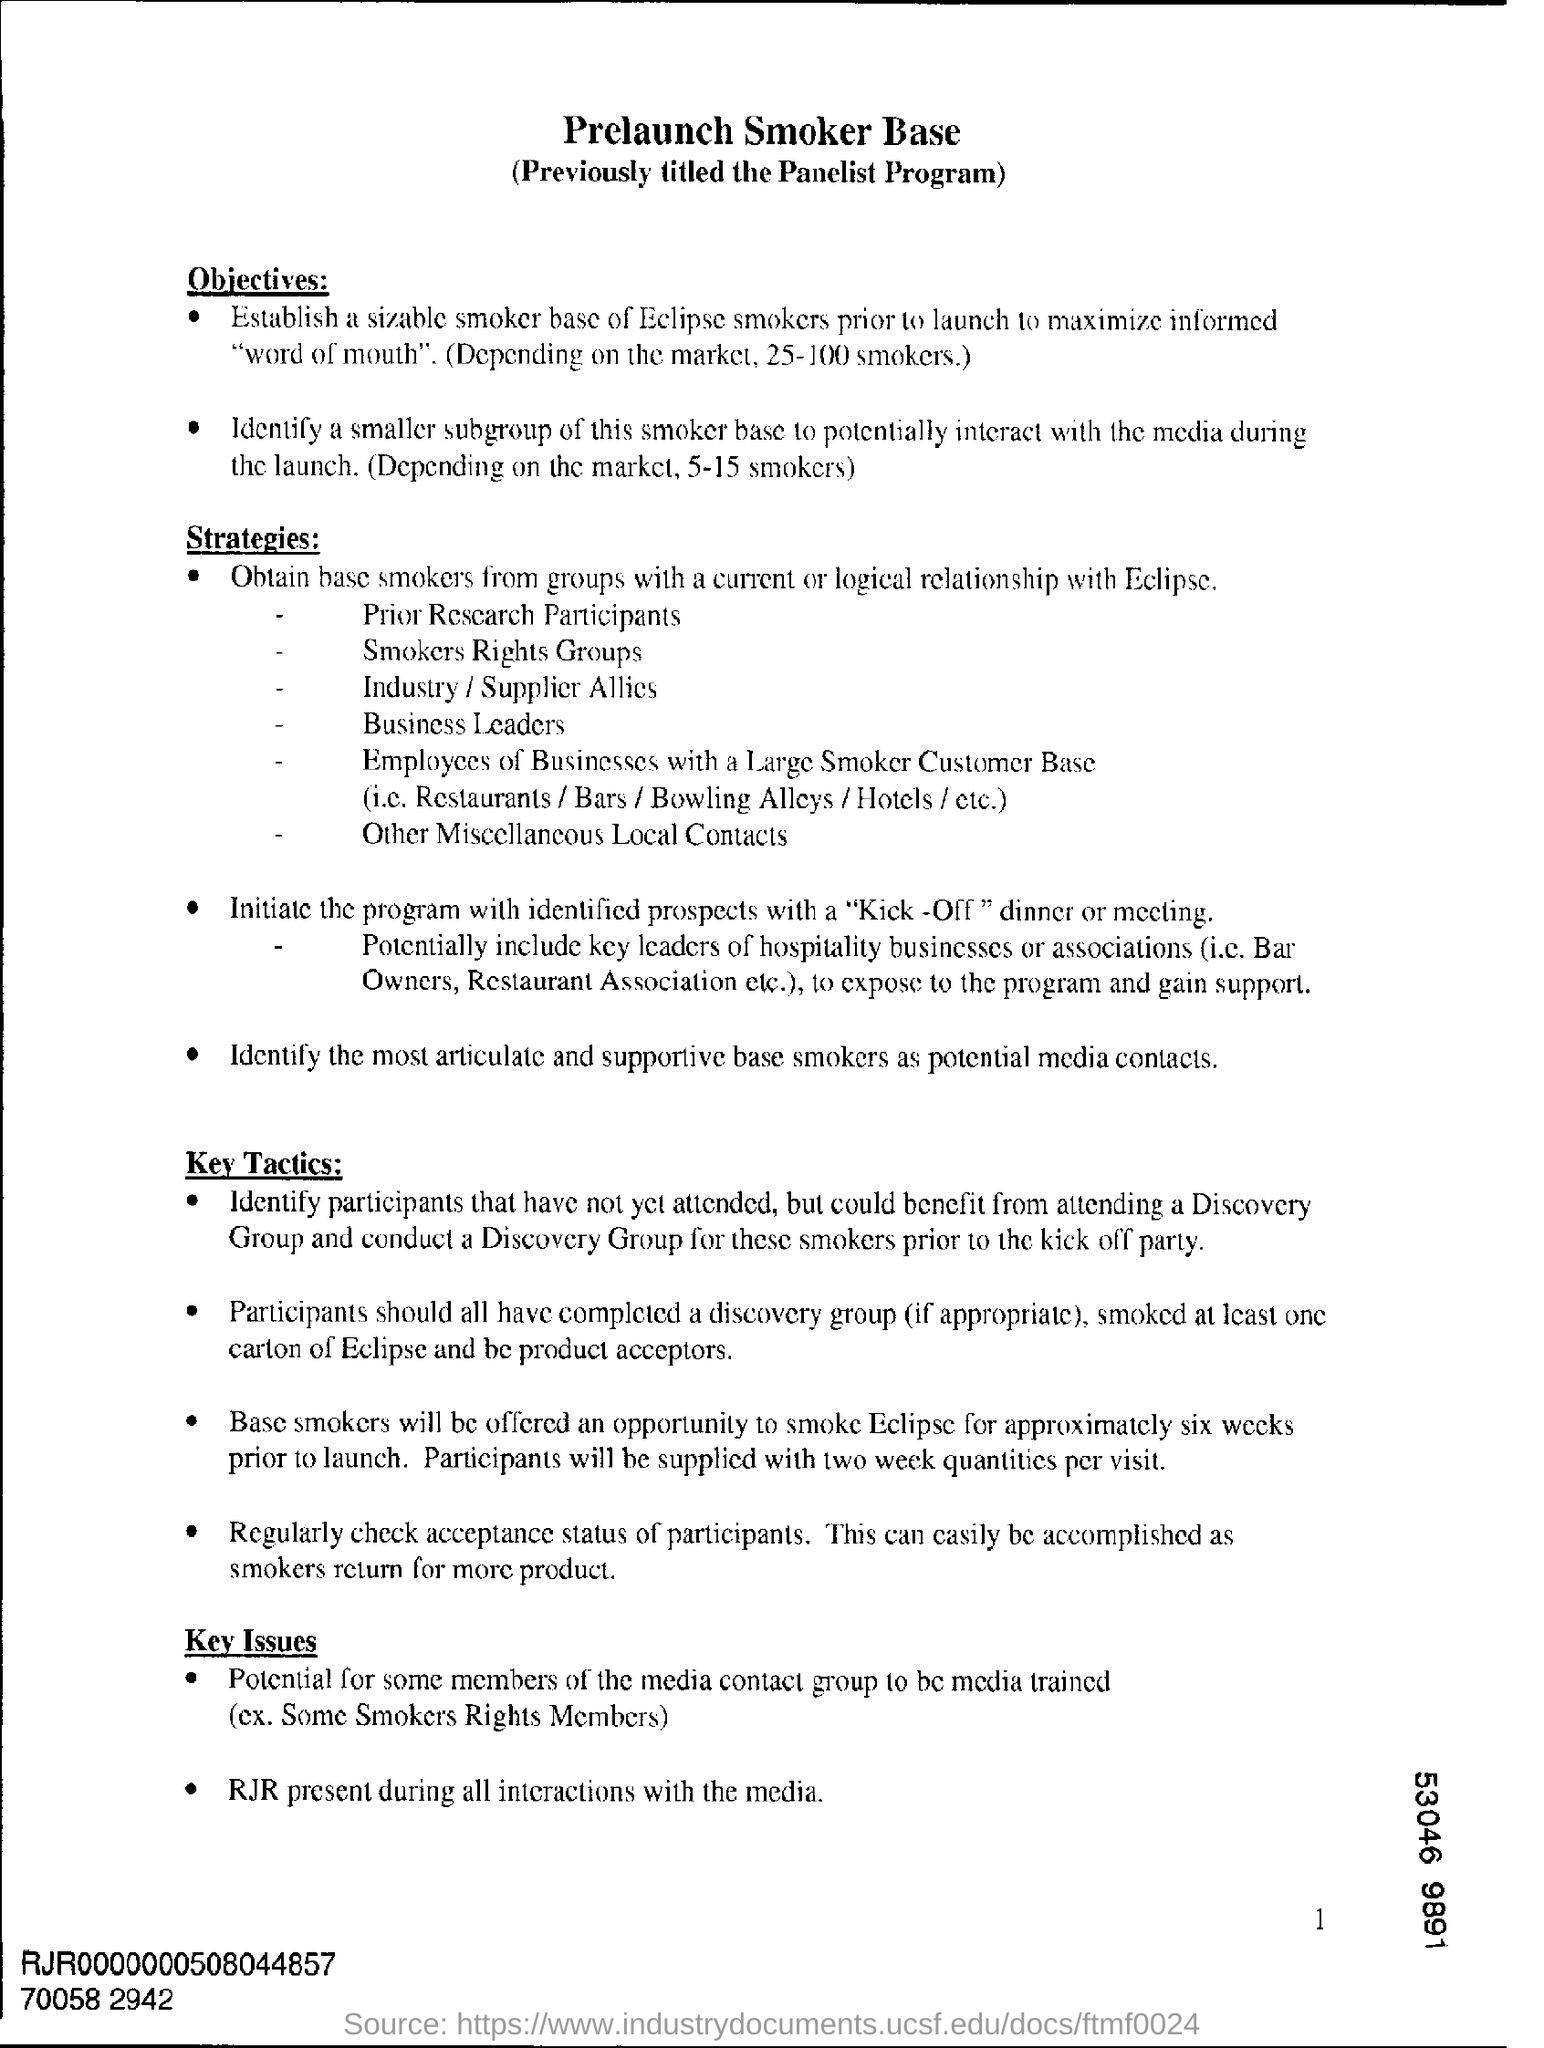What is the heading at top of the page ?
Your response must be concise. Prelaunch smoker base. 